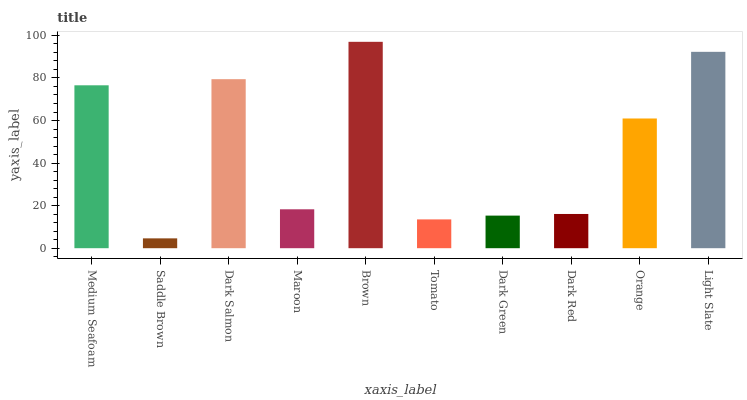Is Saddle Brown the minimum?
Answer yes or no. Yes. Is Brown the maximum?
Answer yes or no. Yes. Is Dark Salmon the minimum?
Answer yes or no. No. Is Dark Salmon the maximum?
Answer yes or no. No. Is Dark Salmon greater than Saddle Brown?
Answer yes or no. Yes. Is Saddle Brown less than Dark Salmon?
Answer yes or no. Yes. Is Saddle Brown greater than Dark Salmon?
Answer yes or no. No. Is Dark Salmon less than Saddle Brown?
Answer yes or no. No. Is Orange the high median?
Answer yes or no. Yes. Is Maroon the low median?
Answer yes or no. Yes. Is Medium Seafoam the high median?
Answer yes or no. No. Is Brown the low median?
Answer yes or no. No. 